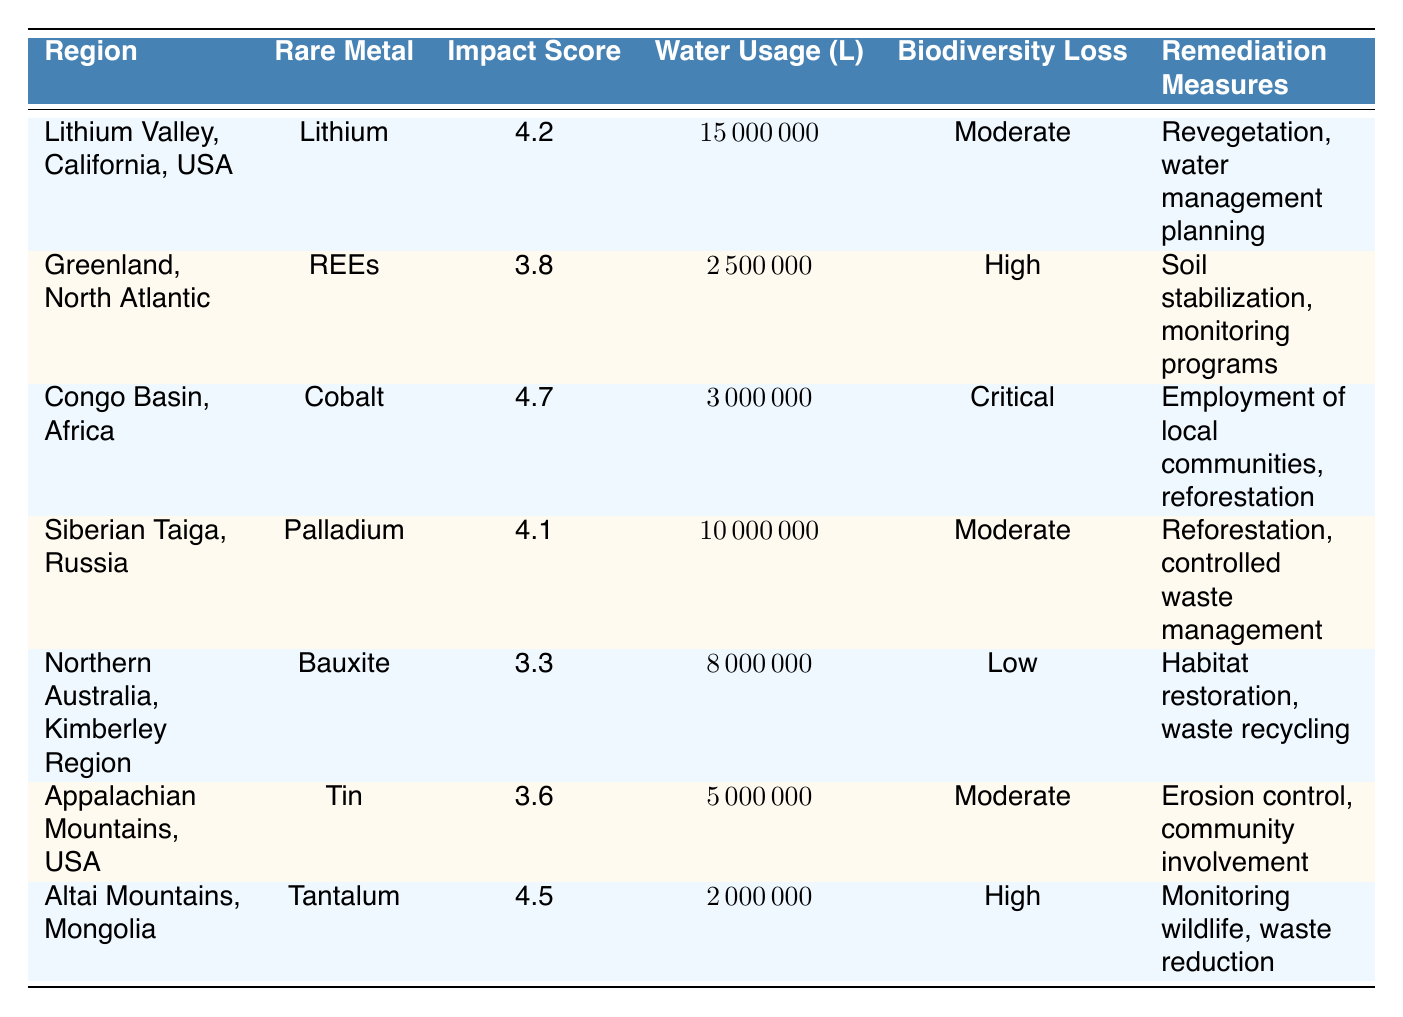What is the environmental impact score for Cobalt in the Congo Basin? The table shows that the environmental impact score for Cobalt in the Congo Basin is 4.7.
Answer: 4.7 Which region has the highest water usage for rare metal extraction? By comparing the water usage values, Lithium Valley, California, USA has the highest usage at 15,000,000 liters.
Answer: Lithium Valley, California, USA Is the biodiversity loss in Northern Australia classified as low? The table indicates that the biodiversity loss in the Northern Australia, Kimberley Region is low, confirming that the statement is true.
Answer: Yes Calculate the average environmental impact score across all listed regions. The impact scores are 4.2, 3.8, 4.7, 4.1, 3.3, 3.6, and 4.5. Summing them gives 28.2, and dividing by 7 regions gives an average of 28.2/7 = 4.03.
Answer: 4.03 What remediation measures are proposed for rare earth extraction in Greenland? The table states that for the extraction in Greenland, the proposed remediation measures include soil stabilization and monitoring programs.
Answer: Soil stabilization, monitoring programs Are all regions listed experiencing high ecosystem disruption? By analyzing the ecosystem disruption levels, both the Congo Basin and Lithium Valley are marked as high, but the other regions have lower classifications, so the statement is false.
Answer: No Which rare metal in the table has the highest environmental impact score? The analysis reveals that Cobalt has the highest score at 4.7 among the listed metals.
Answer: Cobalt If the total water usage for all regions is calculated, what would that amount to? Summing the water usage gives 15,000,000 + 2,500,000 + 3,000,000 + 10,000,000 + 8,000,000 + 5,000,000 + 2,000,000 = 46,500,000 liters.
Answer: 46,500,000 liters Is reforestation among the remediation measures taken in Siberian Taiga for Palladium extraction? Yes, the table states that reforestation is indeed one of the remediation measures for Palladium in Siberian Taiga.
Answer: Yes Find the region where Tantalum extraction has the lowest water usage. Looking at the water usage values, Tantalum extraction in the Altai Mountains uses only 2,000,000 liters, making it the lowest.
Answer: Altai Mountains, Mongolia 